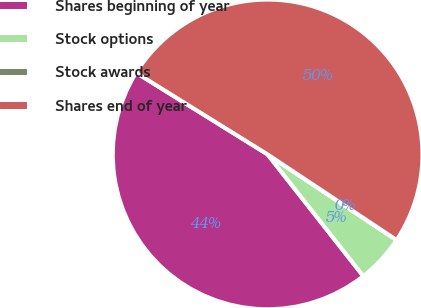Convert chart. <chart><loc_0><loc_0><loc_500><loc_500><pie_chart><fcel>Shares beginning of year<fcel>Stock options<fcel>Stock awards<fcel>Shares end of year<nl><fcel>44.45%<fcel>5.06%<fcel>0.01%<fcel>50.48%<nl></chart> 